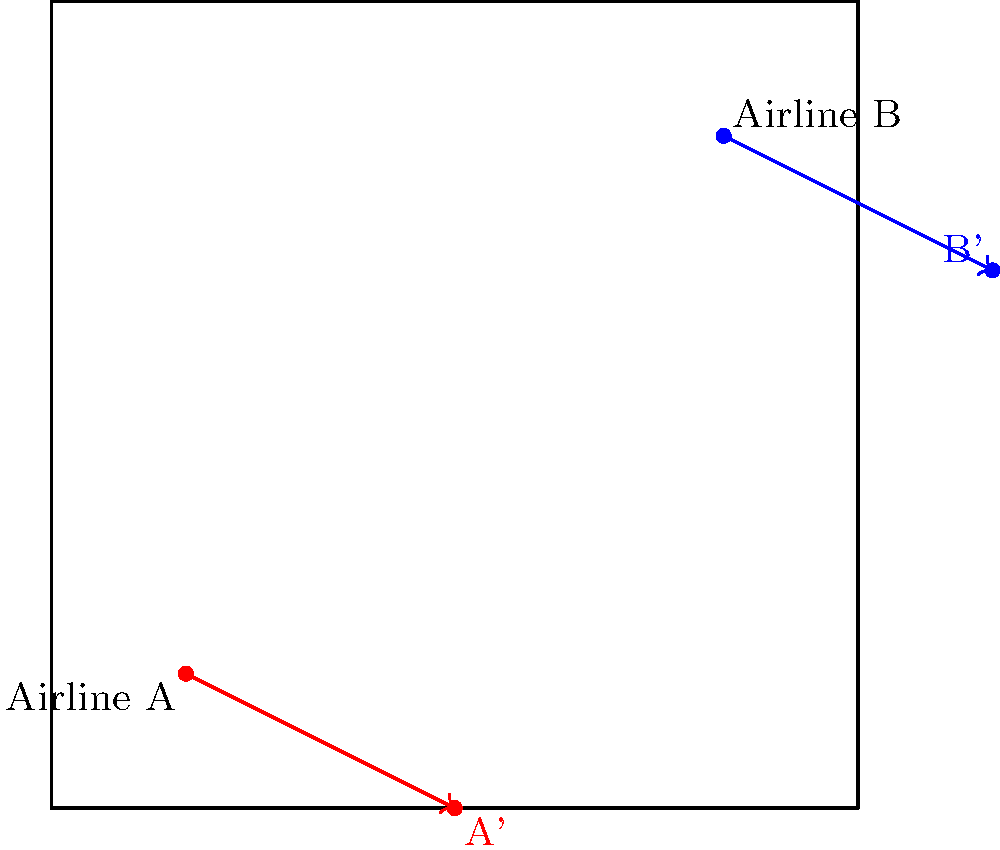Two airlines, A and B, are expanding their routes. Their current hub locations are represented by points on a coordinate plane: A(1,1) and B(5,5). Both airlines are planning to expand their routes by translating their hub locations by the vector $\langle 2, -1 \rangle$. What are the coordinates of the new hub locations for Airlines A and B after this translation? How does this translation reflect the airlines' market expansion strategy? To solve this problem, we need to apply the concept of vector translation in a coordinate plane. Here's a step-by-step explanation:

1) The translation vector is given as $\langle 2, -1 \rangle$. This means we need to add 2 to the x-coordinate and subtract 1 from the y-coordinate of each point.

2) For Airline A:
   Initial coordinates: (1, 1)
   New x-coordinate: $1 + 2 = 3$
   New y-coordinate: $1 + (-1) = 0$
   New coordinates for A: (3, 0)

3) For Airline B:
   Initial coordinates: (5, 5)
   New x-coordinate: $5 + 2 = 7$
   New y-coordinate: $5 + (-1) = 4$
   New coordinates for B: (7, 4)

4) Market expansion strategy interpretation:
   The translation vector $\langle 2, -1 \rangle$ indicates a movement of 2 units east and 1 unit south. This could represent:
   a) Expansion into new markets further east
   b) Slight shift towards southern routes
   c) Possible focus on more cost-effective or less saturated markets

5) The relative positions of the airlines remain the same, indicating they maintain their competitive stance while expanding into new territories.
Answer: A'(3,0), B'(7,4); Eastward expansion with slight southern shift, maintaining competitive positions. 